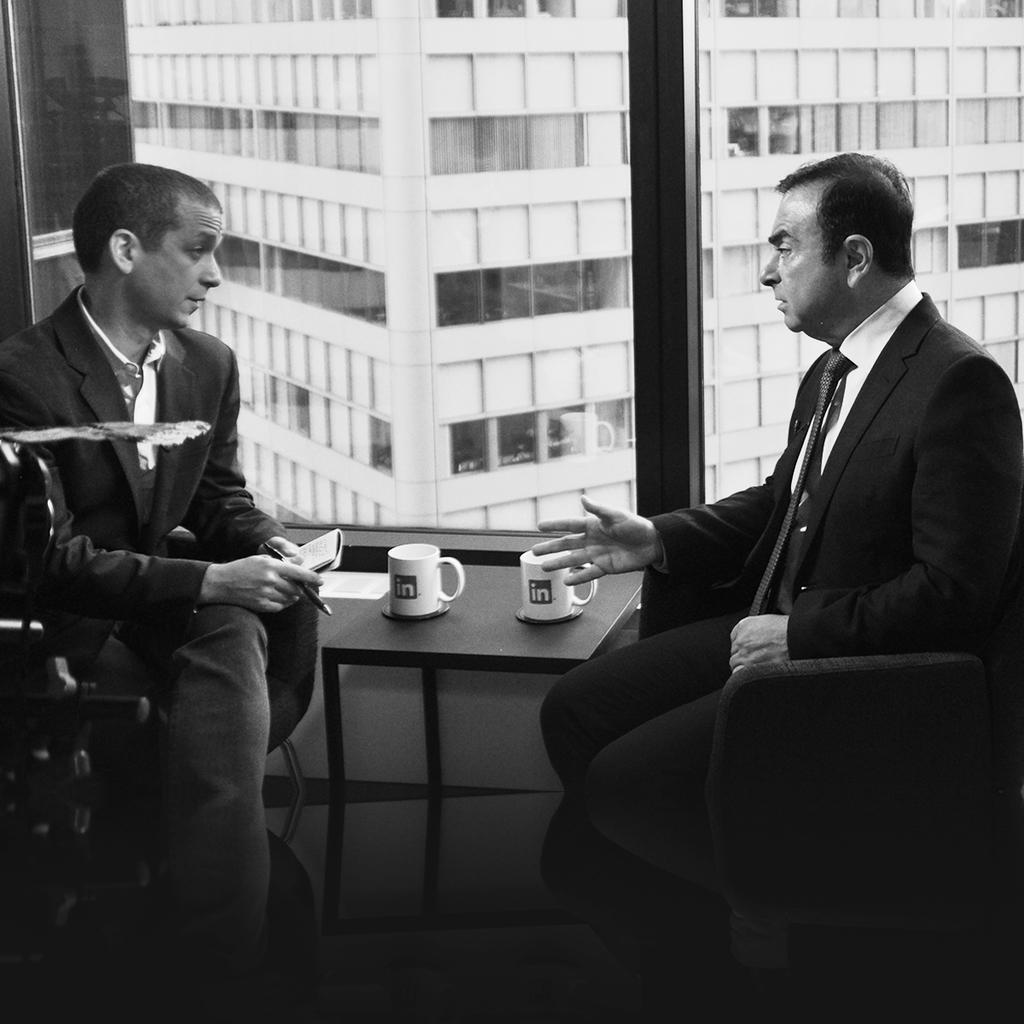Could you give a brief overview of what you see in this image? In this picture I can observe two men sitting on the chairs. In the middle of the picture I can observe two cups on the table. In the background I can observe building. This is a black and white image. 